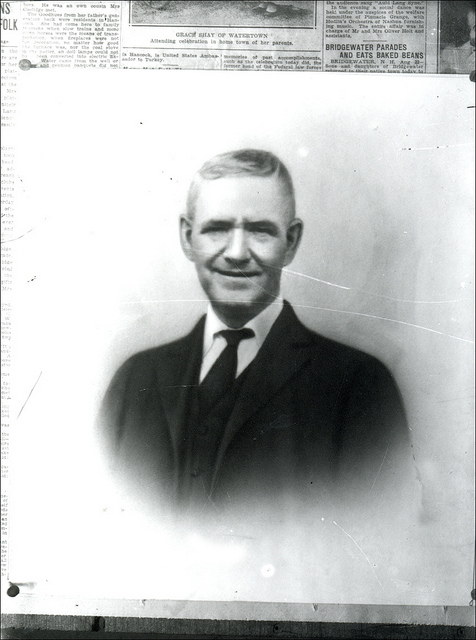Please transcribe the text information in this image. BRIDGEWATER PARADES AND EATS BAXED BEANS NS OLX 